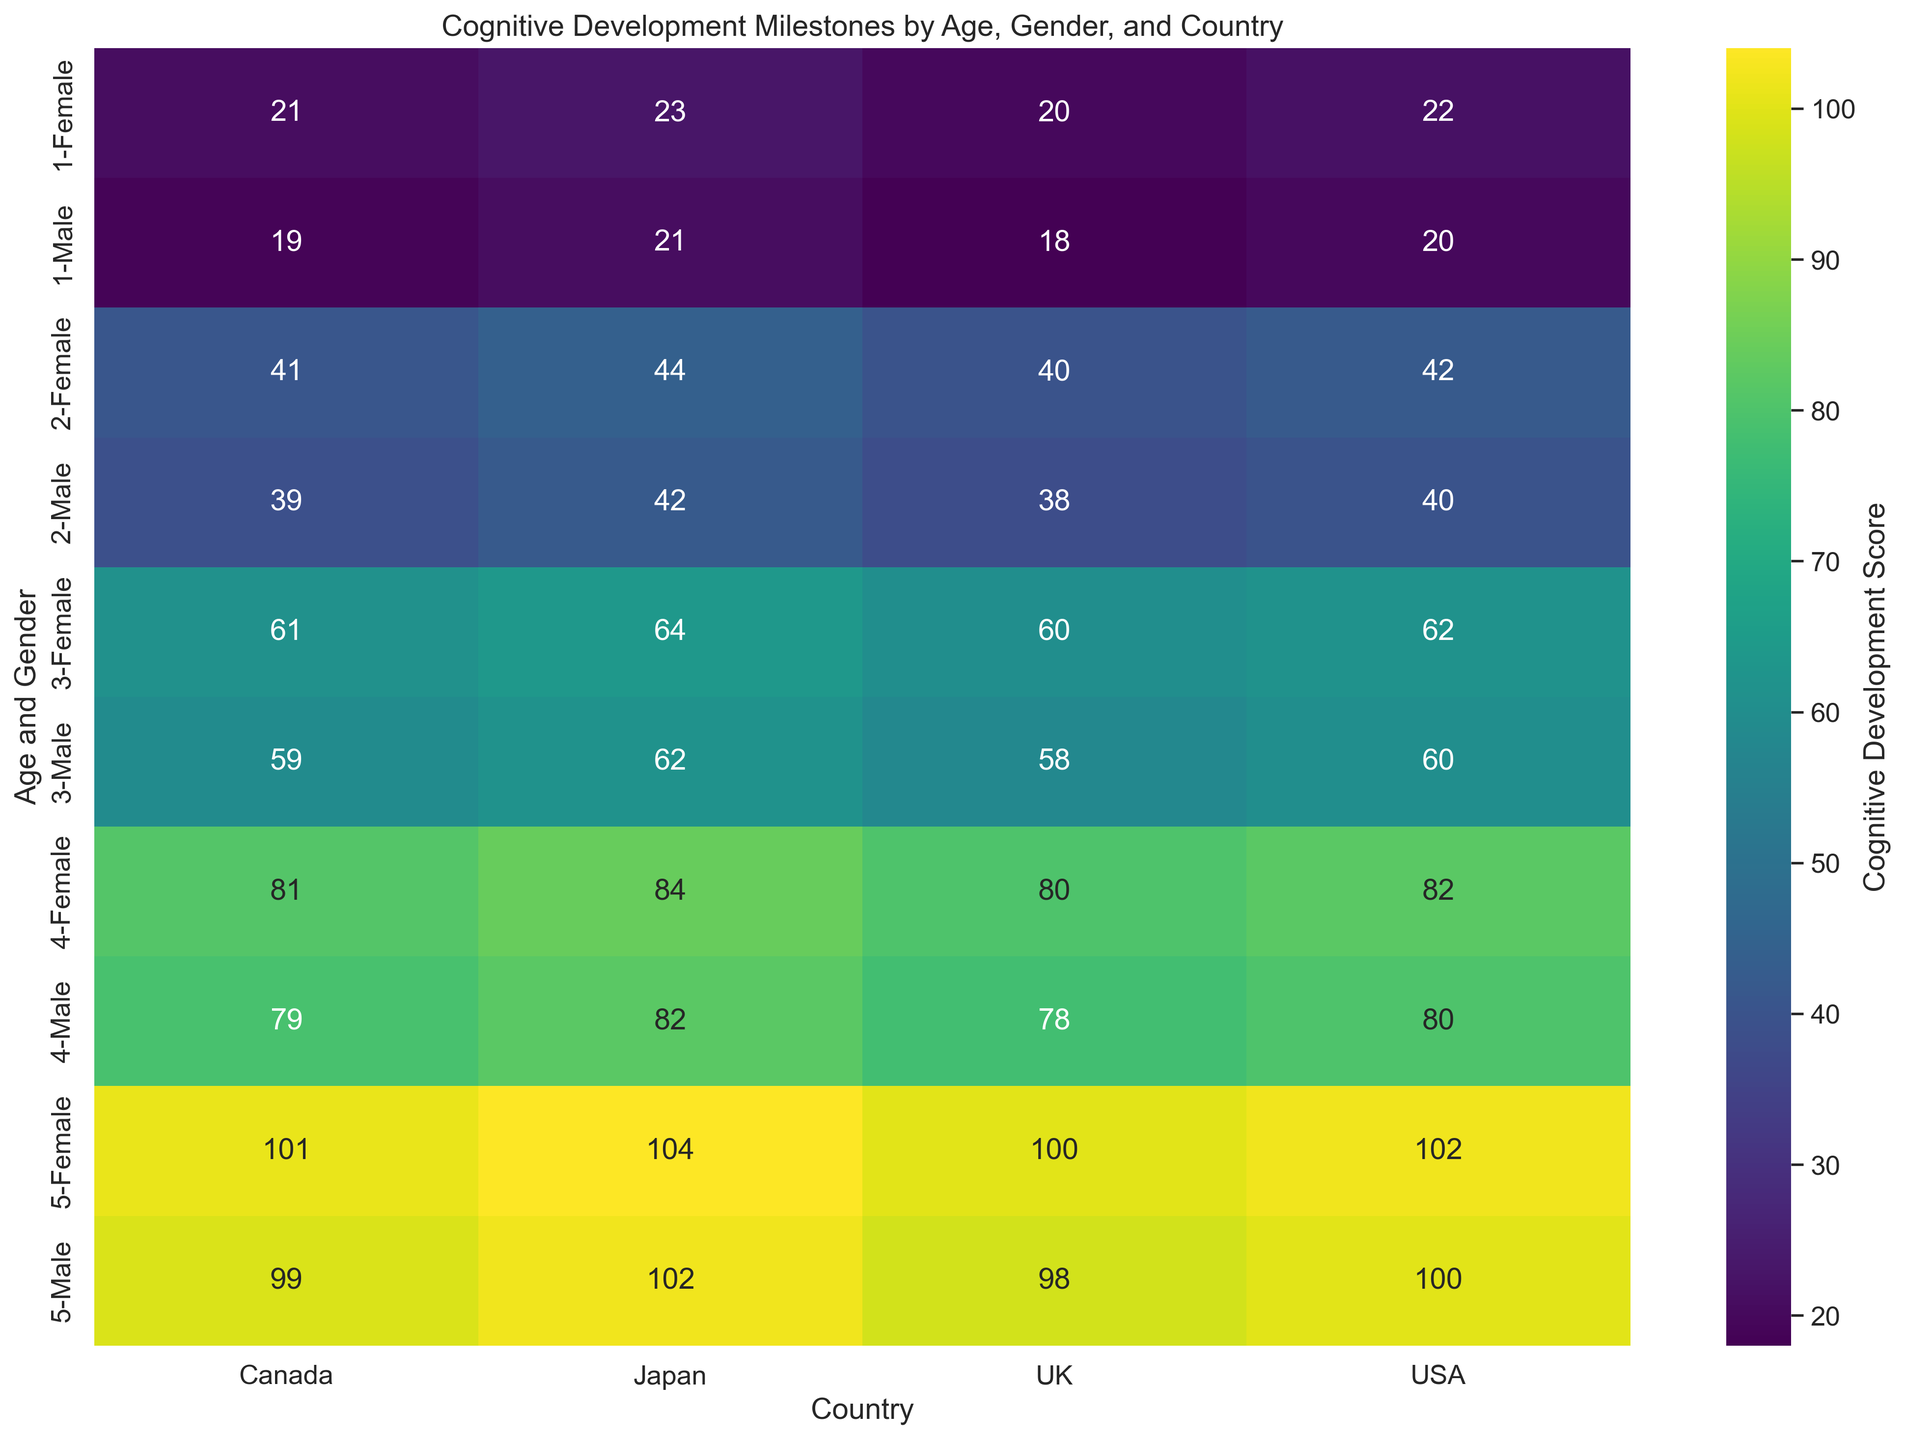What is the average Cognitive Development Score for 1-year-old children across all countries and genders? To find the average, first sum the scores for all 1-year-old children across each country and gender: 20 (Male, USA) + 22 (Female, USA) + 19 (Male, Canada) + 21 (Female, Canada) + 18 (Male, UK) + 20 (Female, UK) + 21 (Male, Japan) + 23 (Female, Japan) = 164. Divide by the number of data points, which is 8, so the average score is 164 / 8 = 20.5
Answer: 20.5 How does the Cognitive Development Score for 2-year-old females in the USA compare to those in Japan? Compare the 2-year-old female score in the USA (42) to the score in Japan (44). Since 44 is greater than 42, Japanese females score higher than American females.
Answer: Japan is higher Among 3-year-old children, which country shows the highest Cognitive Development Score for both males and females? Review the scores for 3-year-old males and females: USA (60, 62), Canada (59, 61), UK (58, 60), Japan (62, 64). Japan has the highest scores for both genders.
Answer: Japan Which age group and gender combination has the lowest Cognitive Development Score? Look at all scores and identify the lowest: 1-year-old Male in the UK has the score of 18.
Answer: 1-year-old Male in the UK What is the difference in Cognitive Development Scores between 5-year-old males in the UK and Canada? Find the score for 5-year-old males in the UK (98) and Canada (99). Calculate the difference: 99 - 98 = 1.
Answer: 1 Do females in each country consistently score higher than males in the same age group? Check each age group in each country: 1-year-old (USA: 22 > 20, Canada: 21 > 19, UK: 20 > 18, Japan: 23 > 21), 2-year-old (USA: 42 > 40, Canada: 41 > 39, UK: 40 > 38, Japan: 44 > 42), 3-year-old (USA: 62 > 60, Canada: 61 > 59, UK: 60 > 58, Japan: 64 > 62), 4-year-old (USA: 82 > 80, Canada: 81 > 79, UK: 80 > 78, Japan: 84 > 82), 5-year-old (USA: 102 > 100, Canada: 101 > 99, UK: 100 > 98, Japan: 104 > 102). In all cases, females score higher.
Answer: Yes Which country shows the most significant increase in Cognitive Development Score from 1-year-olds to 5-year-olds for males? Calculate the increase for each country: 
- USA: 100 - 20 = 80 
- Canada: 99 - 19 = 80 
- UK: 98 - 18 = 80 
- Japan: 102 - 21 = 81. 
Japan shows the highest increase.
Answer: Japan What is the overall trend in Cognitive Development Scores as children age from 1 to 5 years old? Observe the scores across all ages and countries: 1 year (18-23), 2 years (38-44), 3 years (58-64), 4 years (78-84), 5 years (98-104). Scores consistently increase with age.
Answer: Scores increase What is the average score for 4-year-old males in all countries? Sum the scores for 4-year-old males across all countries: USA (80) + Canada (79) + UK (78) + Japan (82) = 319. Divide by the number of countries (4), so the average score is 319 / 4 = 79.75
Answer: 79.75 Compare the cognitive development scores between 2-year-old boys and 4-year-old girls in Canada. Which group scores higher? Compare the scores: 2-year-old boys (39) vs. 4-year-old girls (81) in Canada. The score for 4-year-old girls is higher.
Answer: 4-year-old girls 